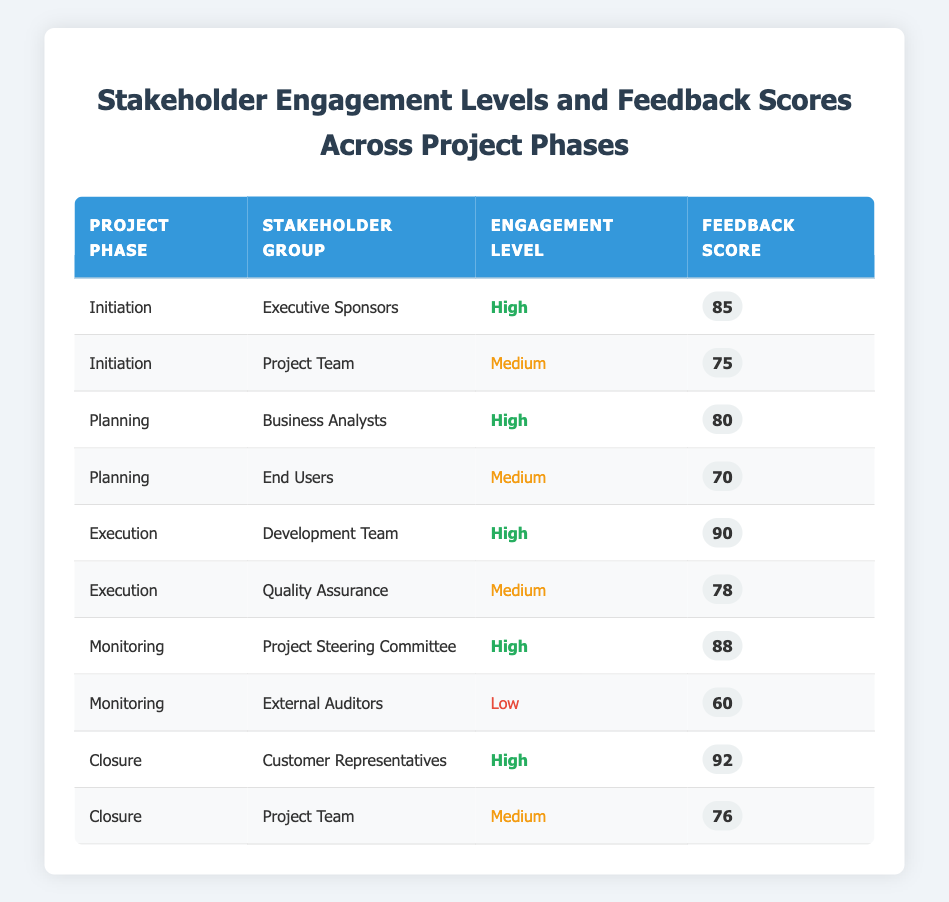What is the feedback score for the Development Team during the Execution phase? The table indicates that the Development Team, during the Execution phase, has a feedback score of 90. This value is found directly in the corresponding row of the table.
Answer: 90 Which stakeholder group received the lowest engagement level? The table shows the External Auditors as having a Low engagement level during the Monitoring phase. This can be identified by scanning the Engagement Level column for the Low status.
Answer: External Auditors What is the average feedback score across all stakeholder groups in the Closure phase? The feedback scores for the Closure phase are 92 for Customer Representatives and 76 for the Project Team. To find the average, we sum these scores: 92 + 76 = 168. There are 2 scores, so the average is 168 / 2 = 84.
Answer: 84 Did any stakeholder group have a feedback score of 85 or higher during the Planning phase? From the table, Business Analysts had a feedback score of 80, while End Users had a feedback score of 70 during the Planning phase. Both are below 85. Therefore, the answer is no.
Answer: No How many stakeholders had a high engagement level in the Initiation and Monitoring phases combined? In the Initiation phase, the Executive Sponsors (1 stakeholder) had a high engagement level. In the Monitoring phase, the Project Steering Committee (1 stakeholder) also had a high engagement level. This gives us a total of 2 stakeholders with high engagement levels in these phases.
Answer: 2 What is the difference in feedback scores between the Customer Representatives and the Project Team in the Closure phase? Customer Representatives had a feedback score of 92, while the Project Team had a score of 76. We calculate the difference: 92 - 76 = 16.
Answer: 16 Which project phase had the highest feedback score and what was that score? Looking through the table, the highest feedback score is 92, recorded in the Closure phase for the Customer Representatives. This can be determined by comparing all feedback scores across the phases.
Answer: 92 Are there any stakeholder groups with medium engagement levels that scored below 75? In the table, the Project Team in the Initiation phase scored 75 and the End Users during Planning phase scored 70. The End Users is below 75, confirming that at least one stakeholder group meets the criteria.
Answer: Yes What is the total feedback score for all stakeholder groups in the Execution phase? In the Execution phase, the feedback scores are 90 for the Development Team and 78 for Quality Assurance. To find the total, we sum these scores: 90 + 78 = 168.
Answer: 168 